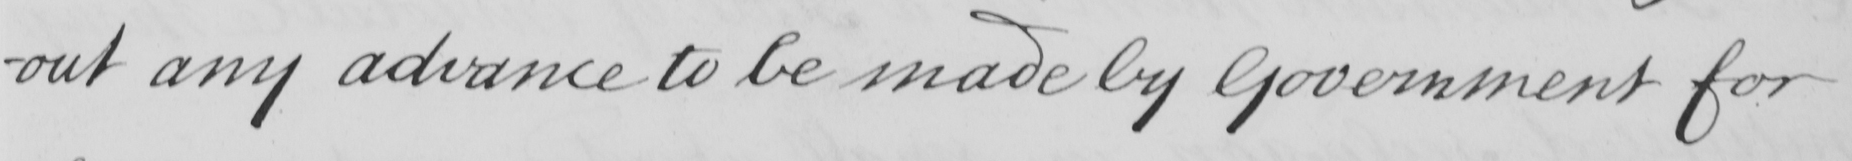What is written in this line of handwriting? -out and advance to be made by Government for 